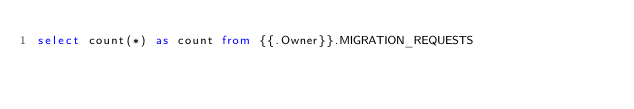<code> <loc_0><loc_0><loc_500><loc_500><_SQL_>select count(*) as count from {{.Owner}}.MIGRATION_REQUESTS
</code> 